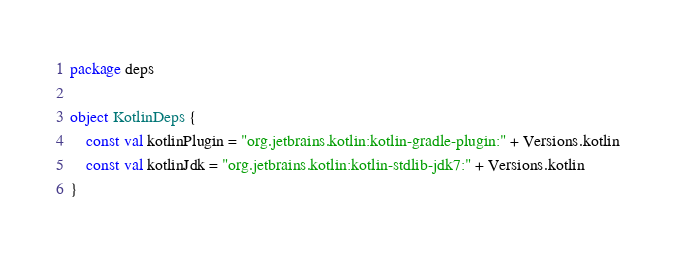<code> <loc_0><loc_0><loc_500><loc_500><_Kotlin_>package deps

object KotlinDeps {
    const val kotlinPlugin = "org.jetbrains.kotlin:kotlin-gradle-plugin:" + Versions.kotlin
    const val kotlinJdk = "org.jetbrains.kotlin:kotlin-stdlib-jdk7:" + Versions.kotlin
}</code> 